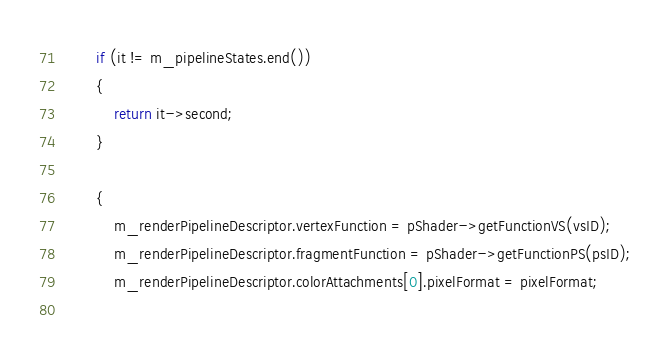Convert code to text. <code><loc_0><loc_0><loc_500><loc_500><_ObjectiveC_>		if (it != m_pipelineStates.end())
		{
			return it->second;
		}
		
		{
			m_renderPipelineDescriptor.vertexFunction = pShader->getFunctionVS(vsID);
			m_renderPipelineDescriptor.fragmentFunction = pShader->getFunctionPS(psID);
			m_renderPipelineDescriptor.colorAttachments[0].pixelFormat = pixelFormat;
			</code> 